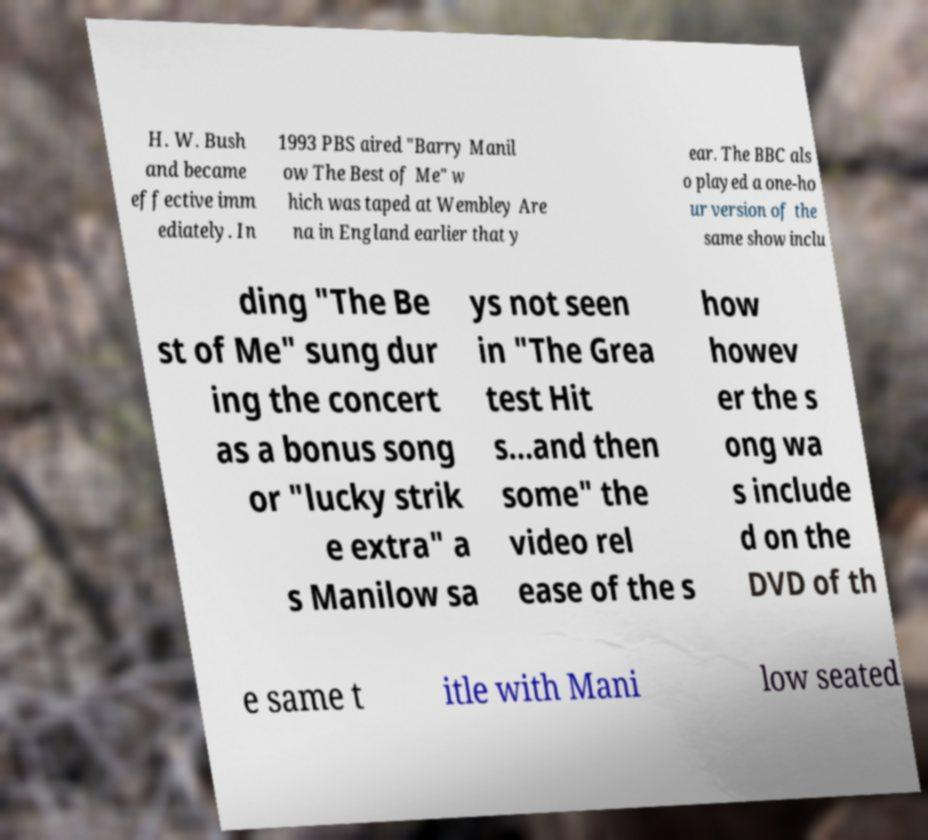There's text embedded in this image that I need extracted. Can you transcribe it verbatim? H. W. Bush and became effective imm ediately. In 1993 PBS aired "Barry Manil ow The Best of Me" w hich was taped at Wembley Are na in England earlier that y ear. The BBC als o played a one-ho ur version of the same show inclu ding "The Be st of Me" sung dur ing the concert as a bonus song or "lucky strik e extra" a s Manilow sa ys not seen in "The Grea test Hit s...and then some" the video rel ease of the s how howev er the s ong wa s include d on the DVD of th e same t itle with Mani low seated 